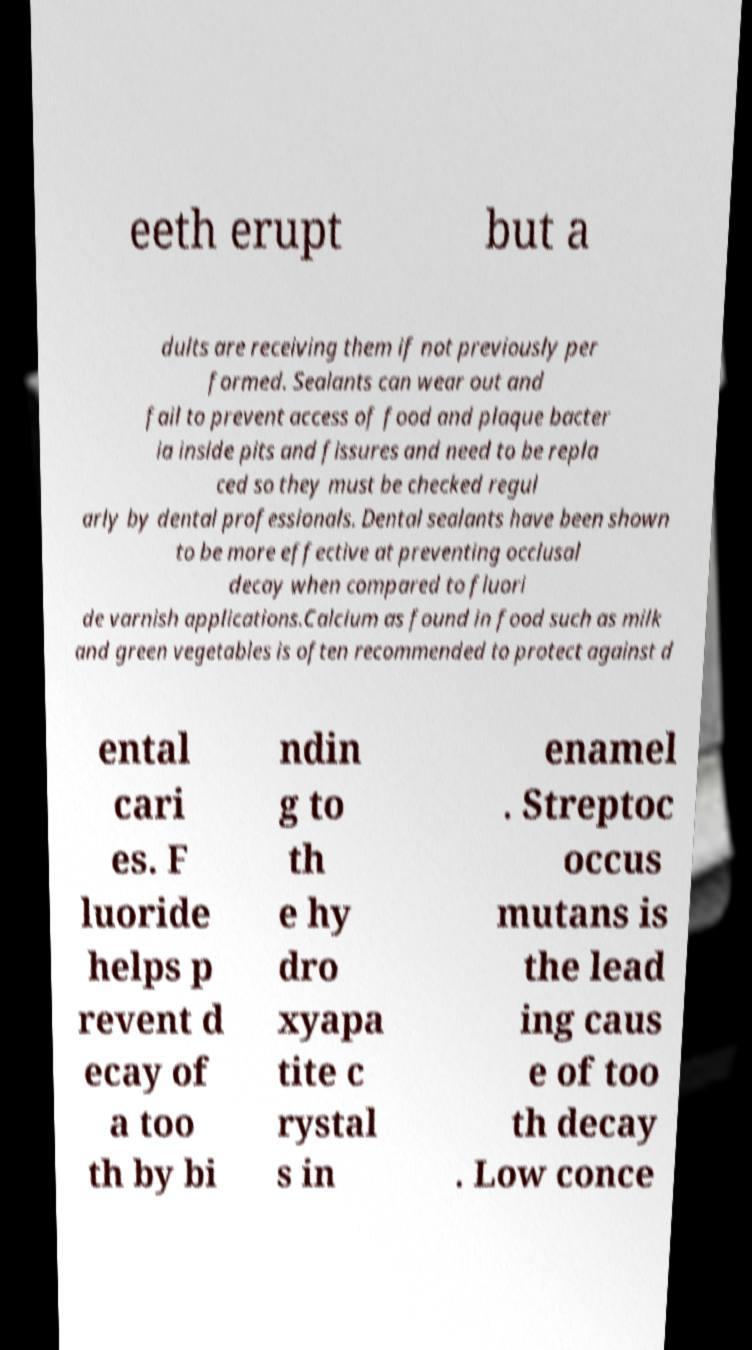Please identify and transcribe the text found in this image. eeth erupt but a dults are receiving them if not previously per formed. Sealants can wear out and fail to prevent access of food and plaque bacter ia inside pits and fissures and need to be repla ced so they must be checked regul arly by dental professionals. Dental sealants have been shown to be more effective at preventing occlusal decay when compared to fluori de varnish applications.Calcium as found in food such as milk and green vegetables is often recommended to protect against d ental cari es. F luoride helps p revent d ecay of a too th by bi ndin g to th e hy dro xyapa tite c rystal s in enamel . Streptoc occus mutans is the lead ing caus e of too th decay . Low conce 